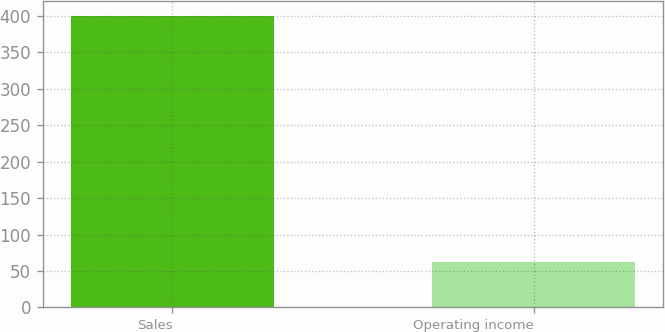Convert chart. <chart><loc_0><loc_0><loc_500><loc_500><bar_chart><fcel>Sales<fcel>Operating income<nl><fcel>400.6<fcel>62.8<nl></chart> 